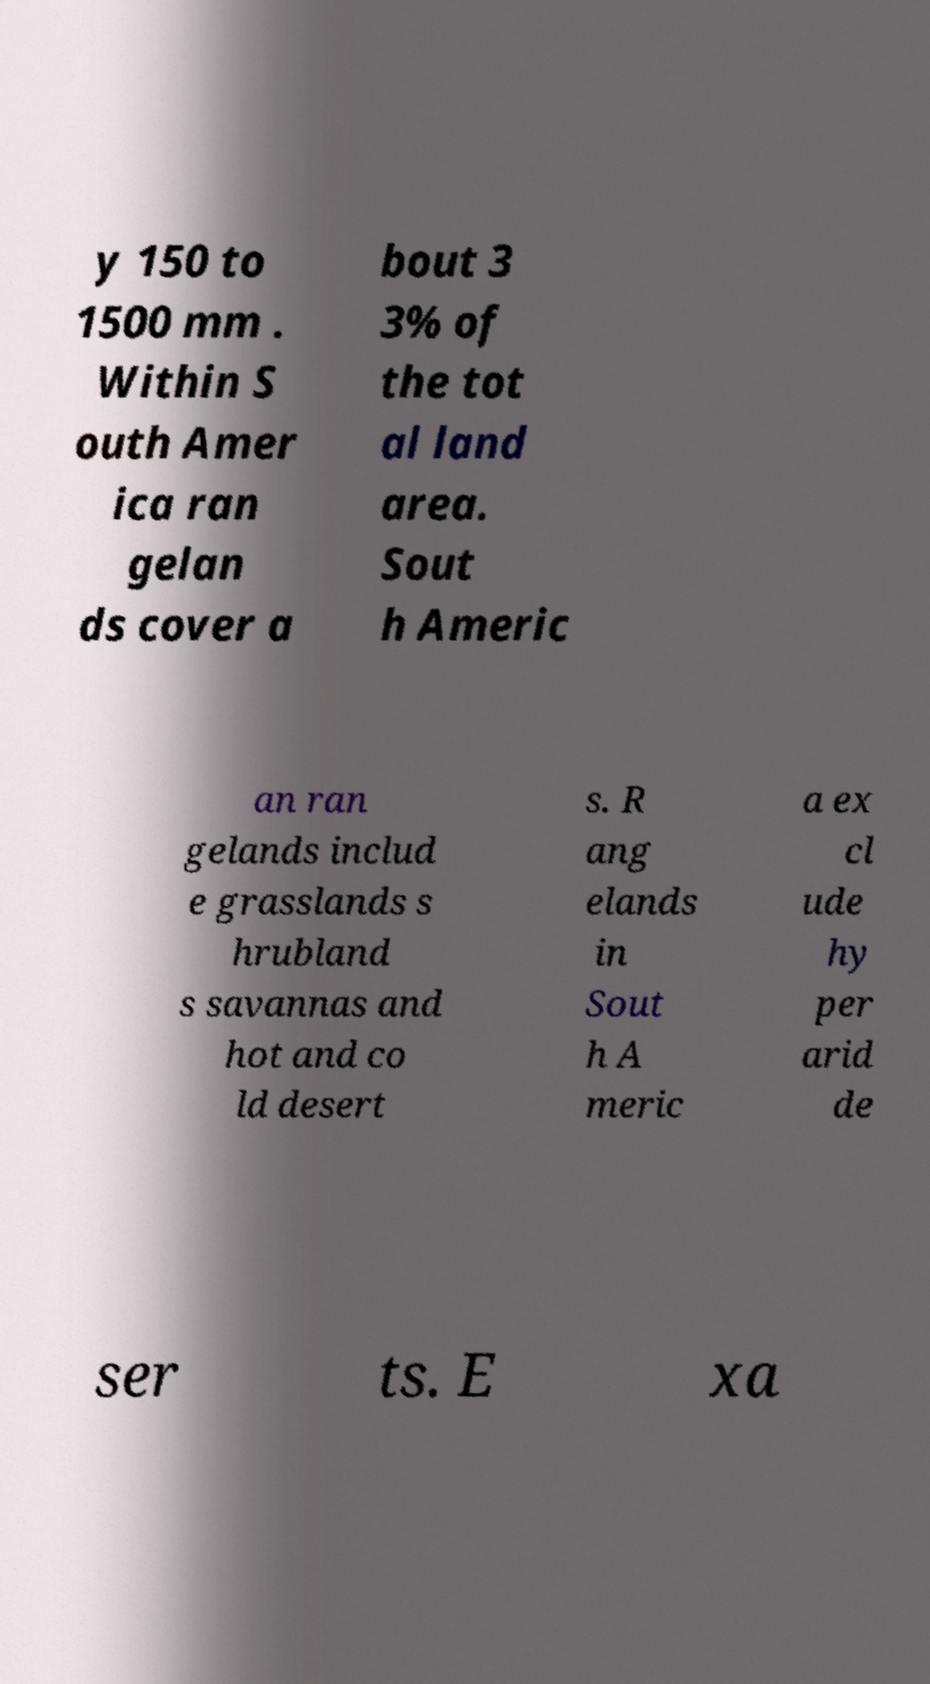For documentation purposes, I need the text within this image transcribed. Could you provide that? y 150 to 1500 mm . Within S outh Amer ica ran gelan ds cover a bout 3 3% of the tot al land area. Sout h Americ an ran gelands includ e grasslands s hrubland s savannas and hot and co ld desert s. R ang elands in Sout h A meric a ex cl ude hy per arid de ser ts. E xa 